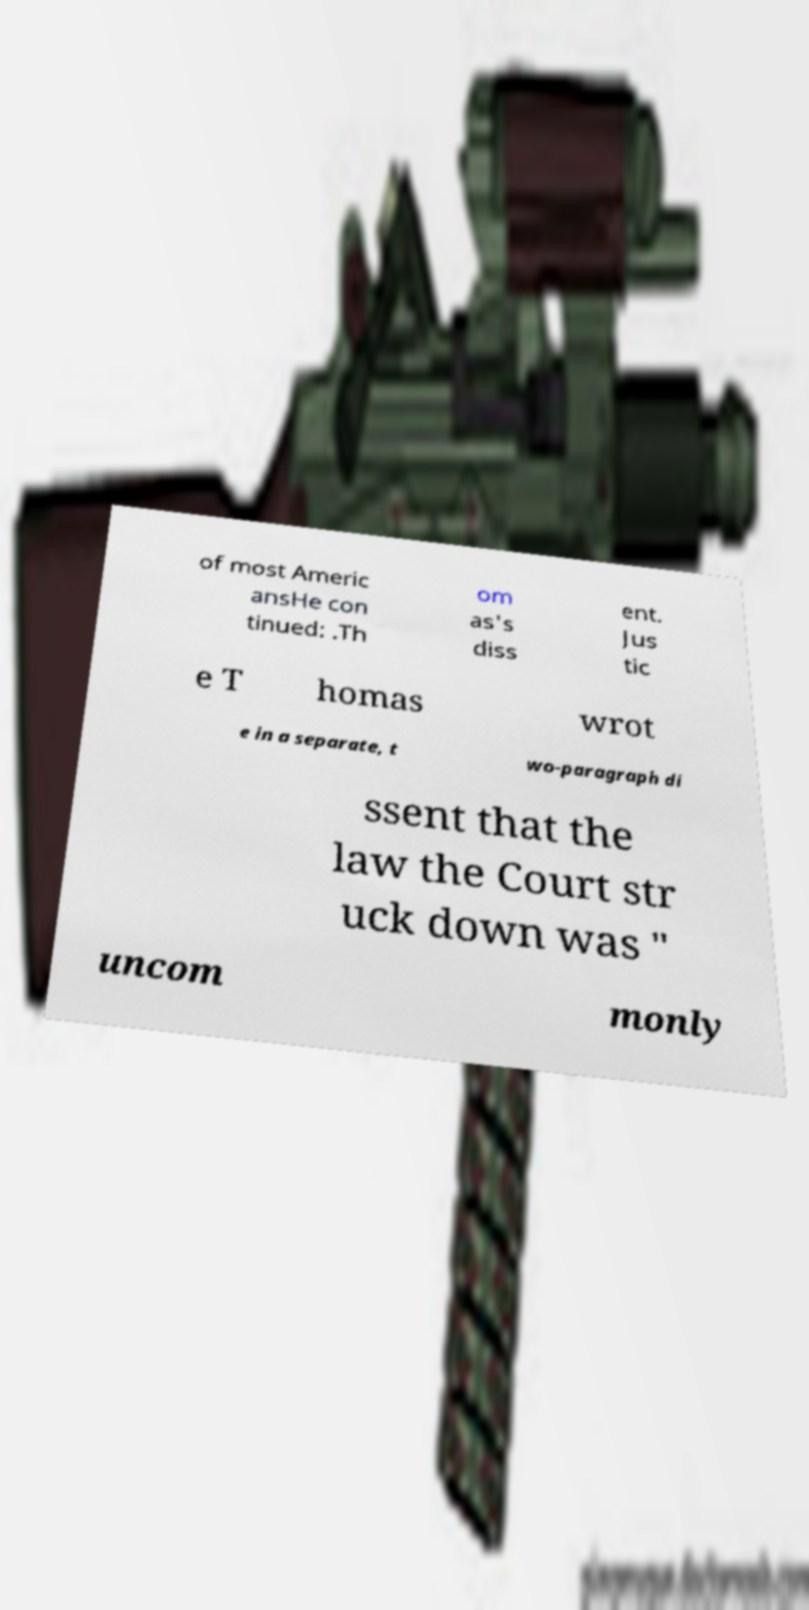Could you assist in decoding the text presented in this image and type it out clearly? of most Americ ansHe con tinued: .Th om as's diss ent. Jus tic e T homas wrot e in a separate, t wo-paragraph di ssent that the law the Court str uck down was " uncom monly 